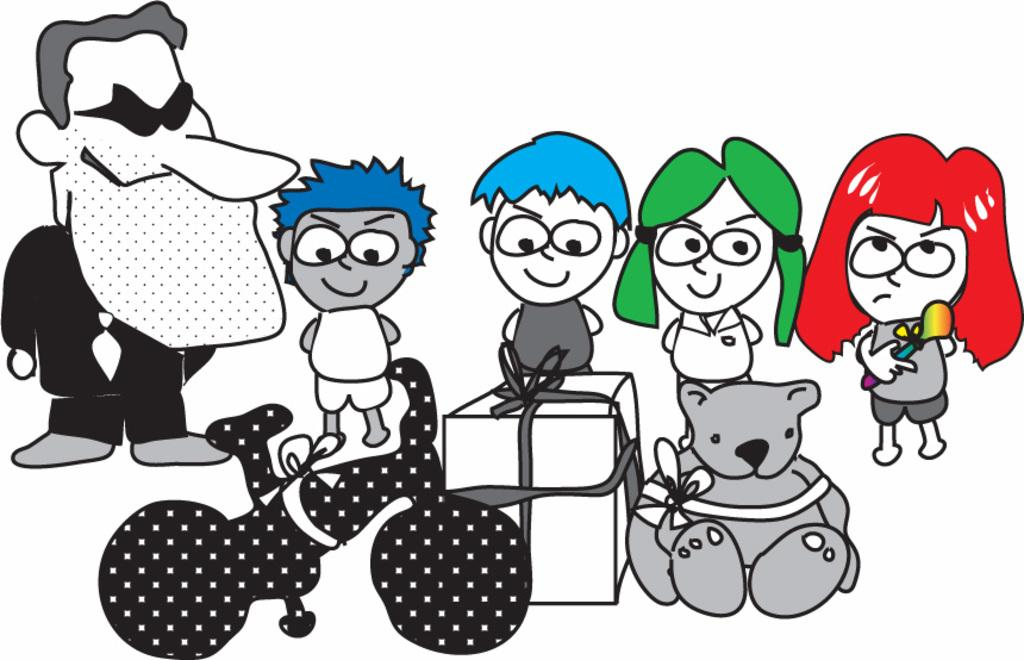What type of content is depicted in the image? There are cartoons in the image. What type of cheese is being served on the airplane in the image? There is no airplane or cheese present in the image; it only features cartoons. 